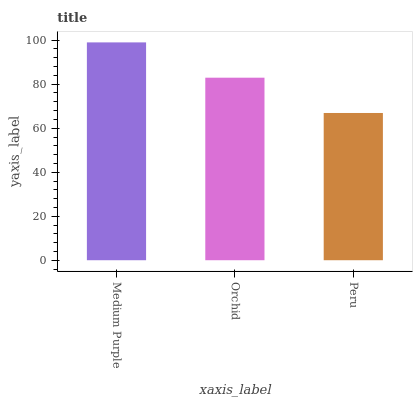Is Orchid the minimum?
Answer yes or no. No. Is Orchid the maximum?
Answer yes or no. No. Is Medium Purple greater than Orchid?
Answer yes or no. Yes. Is Orchid less than Medium Purple?
Answer yes or no. Yes. Is Orchid greater than Medium Purple?
Answer yes or no. No. Is Medium Purple less than Orchid?
Answer yes or no. No. Is Orchid the high median?
Answer yes or no. Yes. Is Orchid the low median?
Answer yes or no. Yes. Is Medium Purple the high median?
Answer yes or no. No. Is Peru the low median?
Answer yes or no. No. 